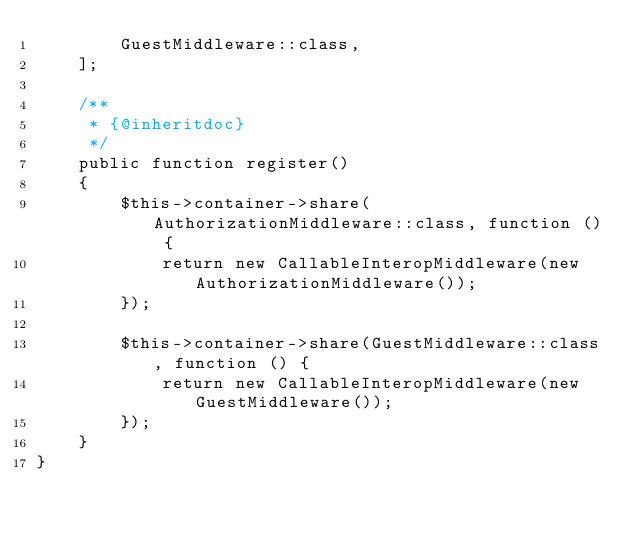<code> <loc_0><loc_0><loc_500><loc_500><_PHP_>        GuestMiddleware::class,
    ];
    
    /**
     * {@inheritdoc}
     */
    public function register()
    {
        $this->container->share(AuthorizationMiddleware::class, function () {
            return new CallableInteropMiddleware(new AuthorizationMiddleware());
        });

        $this->container->share(GuestMiddleware::class, function () {
            return new CallableInteropMiddleware(new GuestMiddleware());
        });
    }
}
</code> 